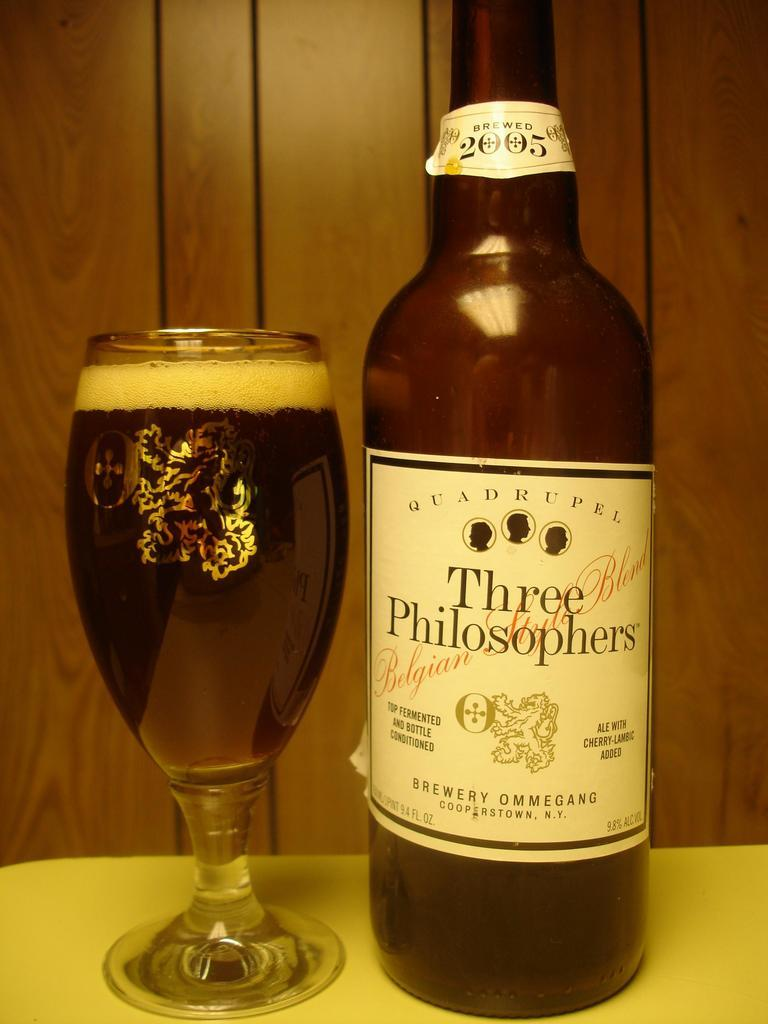<image>
Create a compact narrative representing the image presented. a close up of Three Philosophers beer and a glass 